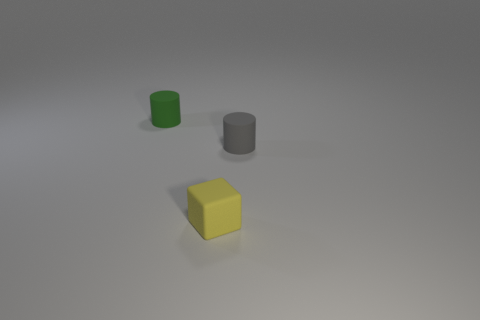What size is the rubber object that is both to the left of the gray cylinder and behind the yellow object?
Make the answer very short. Small. There is a rubber cylinder that is left of the matte cylinder right of the rubber cylinder behind the gray cylinder; what is its size?
Provide a short and direct response. Small. What number of other objects are the same color as the rubber block?
Your answer should be very brief. 0. What number of things are rubber cubes or cylinders?
Your response must be concise. 3. What color is the matte cylinder behind the gray matte cylinder?
Provide a succinct answer. Green. Are there fewer gray matte cylinders that are on the left side of the small cube than tiny yellow matte cubes?
Ensure brevity in your answer.  Yes. Is there any other thing that has the same size as the yellow rubber cube?
Provide a short and direct response. Yes. How many objects are things behind the small yellow block or tiny things that are to the left of the tiny gray cylinder?
Make the answer very short. 3. Is there a gray cylinder of the same size as the rubber block?
Provide a succinct answer. Yes. The other small object that is the same shape as the tiny green rubber object is what color?
Your answer should be compact. Gray. 